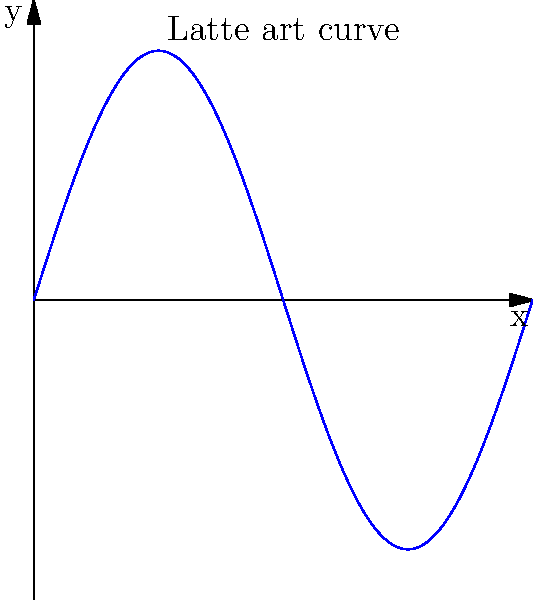As a barrister, you've created a unique latte art design on a customer's coffee. The design can be modeled by the function $y = 0.5\sin(2\pi x)$ for $0 \leq x \leq 1$, where $x$ and $y$ are measured in inches. Calculate the arc length of this latte art design to determine how intricate your creation is. To find the arc length of the latte art design, we'll use the arc length formula:

$$ L = \int_a^b \sqrt{1 + \left(\frac{dy}{dx}\right)^2} dx $$

Steps:
1) First, find $\frac{dy}{dx}$:
   $y = 0.5\sin(2\pi x)$
   $\frac{dy}{dx} = 0.5 \cdot 2\pi \cos(2\pi x) = \pi \cos(2\pi x)$

2) Substitute into the arc length formula:
   $$ L = \int_0^1 \sqrt{1 + (\pi \cos(2\pi x))^2} dx $$

3) This integral can't be solved analytically, so we need to use numerical integration. Using a calculator or computer software with numerical integration capabilities, we can approximate the result:

   $$ L \approx 1.2884 \text{ inches} $$

This means the latte art design you've created has an arc length of approximately 1.2884 inches, demonstrating the intricacy of your work.
Answer: $1.2884 \text{ inches}$ 